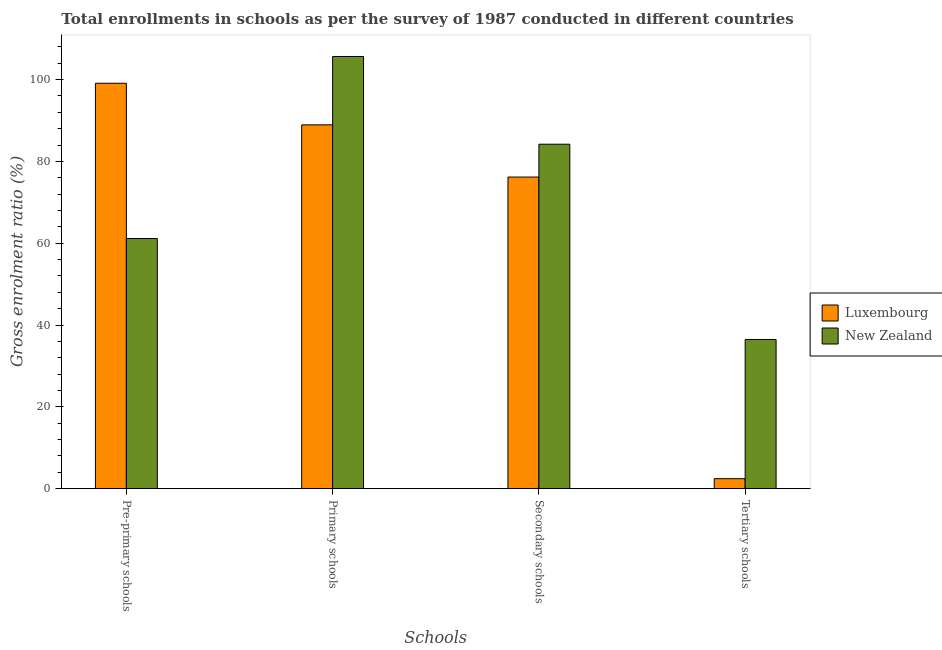How many different coloured bars are there?
Ensure brevity in your answer.  2. How many groups of bars are there?
Your answer should be compact. 4. Are the number of bars per tick equal to the number of legend labels?
Your answer should be very brief. Yes. Are the number of bars on each tick of the X-axis equal?
Your answer should be very brief. Yes. How many bars are there on the 2nd tick from the left?
Ensure brevity in your answer.  2. How many bars are there on the 1st tick from the right?
Offer a very short reply. 2. What is the label of the 2nd group of bars from the left?
Keep it short and to the point. Primary schools. What is the gross enrolment ratio in tertiary schools in New Zealand?
Keep it short and to the point. 36.47. Across all countries, what is the maximum gross enrolment ratio in pre-primary schools?
Provide a succinct answer. 99.09. Across all countries, what is the minimum gross enrolment ratio in secondary schools?
Make the answer very short. 76.17. In which country was the gross enrolment ratio in secondary schools maximum?
Your answer should be compact. New Zealand. In which country was the gross enrolment ratio in secondary schools minimum?
Keep it short and to the point. Luxembourg. What is the total gross enrolment ratio in primary schools in the graph?
Provide a succinct answer. 194.57. What is the difference between the gross enrolment ratio in tertiary schools in New Zealand and that in Luxembourg?
Keep it short and to the point. 34.03. What is the difference between the gross enrolment ratio in secondary schools in New Zealand and the gross enrolment ratio in primary schools in Luxembourg?
Offer a terse response. -4.73. What is the average gross enrolment ratio in secondary schools per country?
Provide a succinct answer. 80.18. What is the difference between the gross enrolment ratio in tertiary schools and gross enrolment ratio in secondary schools in New Zealand?
Ensure brevity in your answer.  -47.73. In how many countries, is the gross enrolment ratio in tertiary schools greater than 36 %?
Provide a succinct answer. 1. What is the ratio of the gross enrolment ratio in secondary schools in New Zealand to that in Luxembourg?
Your answer should be compact. 1.11. Is the gross enrolment ratio in secondary schools in Luxembourg less than that in New Zealand?
Ensure brevity in your answer.  Yes. What is the difference between the highest and the second highest gross enrolment ratio in primary schools?
Ensure brevity in your answer.  16.71. What is the difference between the highest and the lowest gross enrolment ratio in secondary schools?
Provide a short and direct response. 8.03. In how many countries, is the gross enrolment ratio in pre-primary schools greater than the average gross enrolment ratio in pre-primary schools taken over all countries?
Your answer should be compact. 1. Is the sum of the gross enrolment ratio in tertiary schools in Luxembourg and New Zealand greater than the maximum gross enrolment ratio in pre-primary schools across all countries?
Give a very brief answer. No. Is it the case that in every country, the sum of the gross enrolment ratio in primary schools and gross enrolment ratio in secondary schools is greater than the sum of gross enrolment ratio in pre-primary schools and gross enrolment ratio in tertiary schools?
Ensure brevity in your answer.  No. What does the 1st bar from the left in Tertiary schools represents?
Make the answer very short. Luxembourg. What does the 1st bar from the right in Pre-primary schools represents?
Provide a succinct answer. New Zealand. Is it the case that in every country, the sum of the gross enrolment ratio in pre-primary schools and gross enrolment ratio in primary schools is greater than the gross enrolment ratio in secondary schools?
Give a very brief answer. Yes. How many bars are there?
Ensure brevity in your answer.  8. Are all the bars in the graph horizontal?
Offer a terse response. No. How many countries are there in the graph?
Your response must be concise. 2. What is the difference between two consecutive major ticks on the Y-axis?
Provide a succinct answer. 20. Are the values on the major ticks of Y-axis written in scientific E-notation?
Ensure brevity in your answer.  No. How are the legend labels stacked?
Offer a terse response. Vertical. What is the title of the graph?
Offer a very short reply. Total enrollments in schools as per the survey of 1987 conducted in different countries. Does "Israel" appear as one of the legend labels in the graph?
Your answer should be compact. No. What is the label or title of the X-axis?
Your response must be concise. Schools. What is the label or title of the Y-axis?
Keep it short and to the point. Gross enrolment ratio (%). What is the Gross enrolment ratio (%) in Luxembourg in Pre-primary schools?
Your answer should be very brief. 99.09. What is the Gross enrolment ratio (%) in New Zealand in Pre-primary schools?
Keep it short and to the point. 61.15. What is the Gross enrolment ratio (%) in Luxembourg in Primary schools?
Make the answer very short. 88.93. What is the Gross enrolment ratio (%) in New Zealand in Primary schools?
Keep it short and to the point. 105.64. What is the Gross enrolment ratio (%) in Luxembourg in Secondary schools?
Offer a terse response. 76.17. What is the Gross enrolment ratio (%) of New Zealand in Secondary schools?
Your answer should be very brief. 84.2. What is the Gross enrolment ratio (%) of Luxembourg in Tertiary schools?
Your answer should be compact. 2.44. What is the Gross enrolment ratio (%) in New Zealand in Tertiary schools?
Ensure brevity in your answer.  36.47. Across all Schools, what is the maximum Gross enrolment ratio (%) in Luxembourg?
Provide a succinct answer. 99.09. Across all Schools, what is the maximum Gross enrolment ratio (%) in New Zealand?
Your answer should be very brief. 105.64. Across all Schools, what is the minimum Gross enrolment ratio (%) of Luxembourg?
Provide a succinct answer. 2.44. Across all Schools, what is the minimum Gross enrolment ratio (%) of New Zealand?
Provide a short and direct response. 36.47. What is the total Gross enrolment ratio (%) of Luxembourg in the graph?
Your answer should be very brief. 266.63. What is the total Gross enrolment ratio (%) of New Zealand in the graph?
Your answer should be compact. 287.45. What is the difference between the Gross enrolment ratio (%) in Luxembourg in Pre-primary schools and that in Primary schools?
Provide a short and direct response. 10.17. What is the difference between the Gross enrolment ratio (%) of New Zealand in Pre-primary schools and that in Primary schools?
Keep it short and to the point. -44.49. What is the difference between the Gross enrolment ratio (%) in Luxembourg in Pre-primary schools and that in Secondary schools?
Provide a short and direct response. 22.92. What is the difference between the Gross enrolment ratio (%) in New Zealand in Pre-primary schools and that in Secondary schools?
Your response must be concise. -23.05. What is the difference between the Gross enrolment ratio (%) of Luxembourg in Pre-primary schools and that in Tertiary schools?
Provide a short and direct response. 96.66. What is the difference between the Gross enrolment ratio (%) of New Zealand in Pre-primary schools and that in Tertiary schools?
Provide a short and direct response. 24.68. What is the difference between the Gross enrolment ratio (%) of Luxembourg in Primary schools and that in Secondary schools?
Offer a very short reply. 12.76. What is the difference between the Gross enrolment ratio (%) in New Zealand in Primary schools and that in Secondary schools?
Provide a short and direct response. 21.44. What is the difference between the Gross enrolment ratio (%) in Luxembourg in Primary schools and that in Tertiary schools?
Your answer should be very brief. 86.49. What is the difference between the Gross enrolment ratio (%) in New Zealand in Primary schools and that in Tertiary schools?
Give a very brief answer. 69.17. What is the difference between the Gross enrolment ratio (%) in Luxembourg in Secondary schools and that in Tertiary schools?
Make the answer very short. 73.73. What is the difference between the Gross enrolment ratio (%) of New Zealand in Secondary schools and that in Tertiary schools?
Provide a short and direct response. 47.73. What is the difference between the Gross enrolment ratio (%) of Luxembourg in Pre-primary schools and the Gross enrolment ratio (%) of New Zealand in Primary schools?
Offer a very short reply. -6.55. What is the difference between the Gross enrolment ratio (%) of Luxembourg in Pre-primary schools and the Gross enrolment ratio (%) of New Zealand in Secondary schools?
Give a very brief answer. 14.9. What is the difference between the Gross enrolment ratio (%) of Luxembourg in Pre-primary schools and the Gross enrolment ratio (%) of New Zealand in Tertiary schools?
Provide a short and direct response. 62.62. What is the difference between the Gross enrolment ratio (%) of Luxembourg in Primary schools and the Gross enrolment ratio (%) of New Zealand in Secondary schools?
Keep it short and to the point. 4.73. What is the difference between the Gross enrolment ratio (%) in Luxembourg in Primary schools and the Gross enrolment ratio (%) in New Zealand in Tertiary schools?
Ensure brevity in your answer.  52.46. What is the difference between the Gross enrolment ratio (%) in Luxembourg in Secondary schools and the Gross enrolment ratio (%) in New Zealand in Tertiary schools?
Make the answer very short. 39.7. What is the average Gross enrolment ratio (%) of Luxembourg per Schools?
Make the answer very short. 66.66. What is the average Gross enrolment ratio (%) of New Zealand per Schools?
Offer a very short reply. 71.86. What is the difference between the Gross enrolment ratio (%) of Luxembourg and Gross enrolment ratio (%) of New Zealand in Pre-primary schools?
Your response must be concise. 37.95. What is the difference between the Gross enrolment ratio (%) of Luxembourg and Gross enrolment ratio (%) of New Zealand in Primary schools?
Ensure brevity in your answer.  -16.71. What is the difference between the Gross enrolment ratio (%) in Luxembourg and Gross enrolment ratio (%) in New Zealand in Secondary schools?
Offer a terse response. -8.03. What is the difference between the Gross enrolment ratio (%) of Luxembourg and Gross enrolment ratio (%) of New Zealand in Tertiary schools?
Make the answer very short. -34.03. What is the ratio of the Gross enrolment ratio (%) of Luxembourg in Pre-primary schools to that in Primary schools?
Your answer should be very brief. 1.11. What is the ratio of the Gross enrolment ratio (%) of New Zealand in Pre-primary schools to that in Primary schools?
Make the answer very short. 0.58. What is the ratio of the Gross enrolment ratio (%) of Luxembourg in Pre-primary schools to that in Secondary schools?
Offer a terse response. 1.3. What is the ratio of the Gross enrolment ratio (%) in New Zealand in Pre-primary schools to that in Secondary schools?
Make the answer very short. 0.73. What is the ratio of the Gross enrolment ratio (%) of Luxembourg in Pre-primary schools to that in Tertiary schools?
Make the answer very short. 40.63. What is the ratio of the Gross enrolment ratio (%) in New Zealand in Pre-primary schools to that in Tertiary schools?
Give a very brief answer. 1.68. What is the ratio of the Gross enrolment ratio (%) in Luxembourg in Primary schools to that in Secondary schools?
Your answer should be compact. 1.17. What is the ratio of the Gross enrolment ratio (%) of New Zealand in Primary schools to that in Secondary schools?
Your answer should be very brief. 1.25. What is the ratio of the Gross enrolment ratio (%) in Luxembourg in Primary schools to that in Tertiary schools?
Keep it short and to the point. 36.46. What is the ratio of the Gross enrolment ratio (%) in New Zealand in Primary schools to that in Tertiary schools?
Offer a terse response. 2.9. What is the ratio of the Gross enrolment ratio (%) in Luxembourg in Secondary schools to that in Tertiary schools?
Give a very brief answer. 31.23. What is the ratio of the Gross enrolment ratio (%) in New Zealand in Secondary schools to that in Tertiary schools?
Provide a succinct answer. 2.31. What is the difference between the highest and the second highest Gross enrolment ratio (%) in Luxembourg?
Make the answer very short. 10.17. What is the difference between the highest and the second highest Gross enrolment ratio (%) in New Zealand?
Your response must be concise. 21.44. What is the difference between the highest and the lowest Gross enrolment ratio (%) of Luxembourg?
Make the answer very short. 96.66. What is the difference between the highest and the lowest Gross enrolment ratio (%) of New Zealand?
Keep it short and to the point. 69.17. 